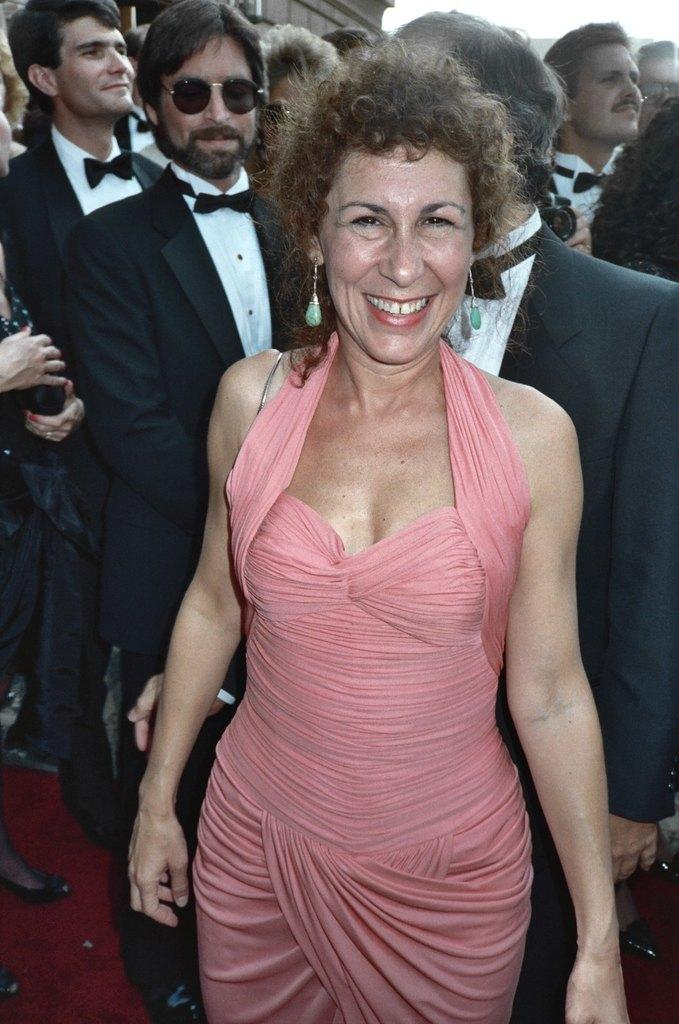What is happening in the image? There are persons standing in the image. Can you describe the attire of one of the ladies? A lady is wearing a pink color dress. Are there any specific types of suits being worn by some of the persons? Yes, there are persons wearing black and white suits in the image. How many ducks are visible in the image? There are no ducks present in the image. What type of space-related equipment can be seen in the image? There is no space-related equipment present in the image. 